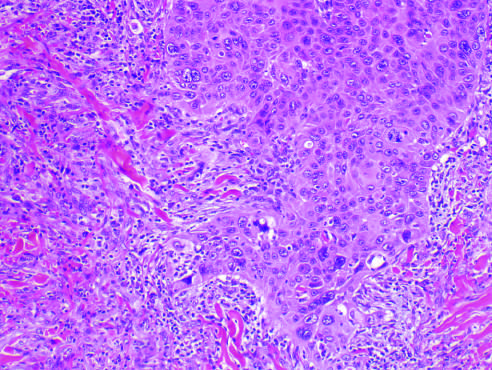what invades the dermal soft tissue as irregular projections of atypical squamous cells exhibiting acantholysis?
Answer the question using a single word or phrase. The tumor 